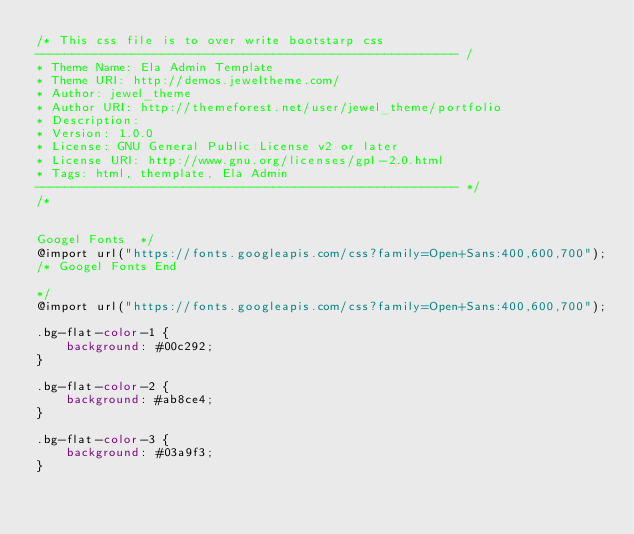Convert code to text. <code><loc_0><loc_0><loc_500><loc_500><_CSS_>/* This css file is to over write bootstarp css
--------------------------------------------------------- /
* Theme Name: Ela Admin Template
* Theme URI: http://demos.jeweltheme.com/
* Author: jewel_theme
* Author URI: http://themeforest.net/user/jewel_theme/portfolio
* Description:
* Version: 1.0.0
* License: GNU General Public License v2 or later
* License URI: http://www.gnu.org/licenses/gpl-2.0.html
* Tags: html, themplate, Ela Admin
--------------------------------------------------------- */
/* 


Googel Fonts  */
@import url("https://fonts.googleapis.com/css?family=Open+Sans:400,600,700");
/* Googel Fonts End  

*/
@import url("https://fonts.googleapis.com/css?family=Open+Sans:400,600,700");

.bg-flat-color-1 {
    background: #00c292;
}

.bg-flat-color-2 {
    background: #ab8ce4;
}

.bg-flat-color-3 {
    background: #03a9f3;
}
</code> 